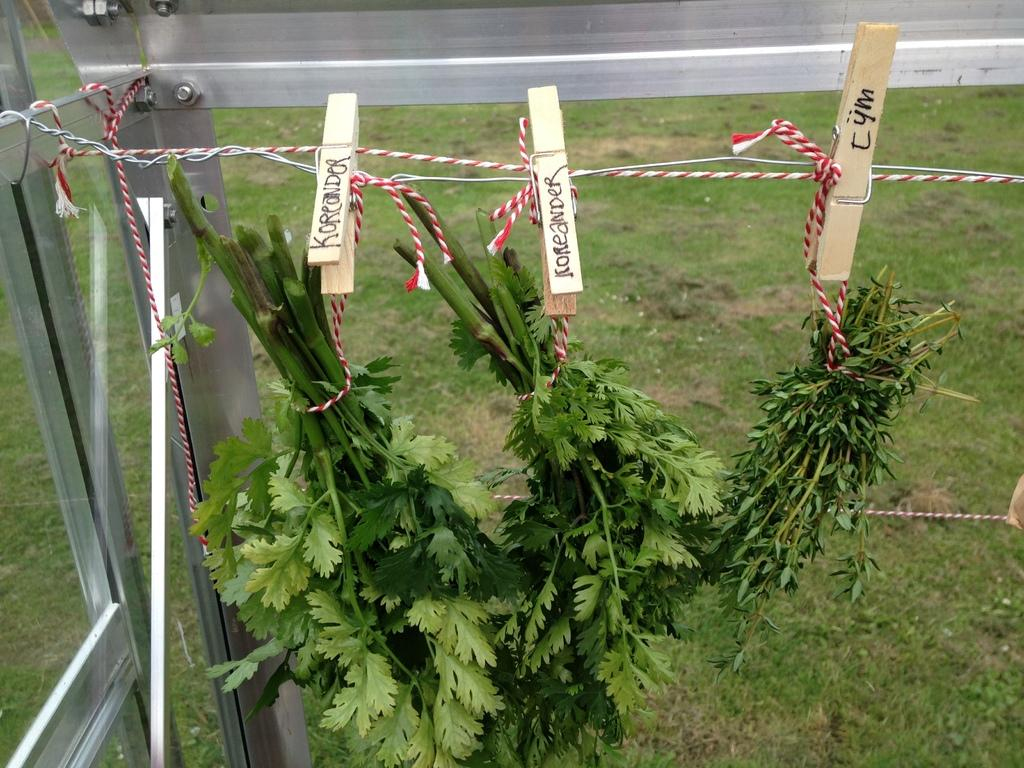<image>
Summarize the visual content of the image. Koriander and tym herbs hang from a metal rack outside 